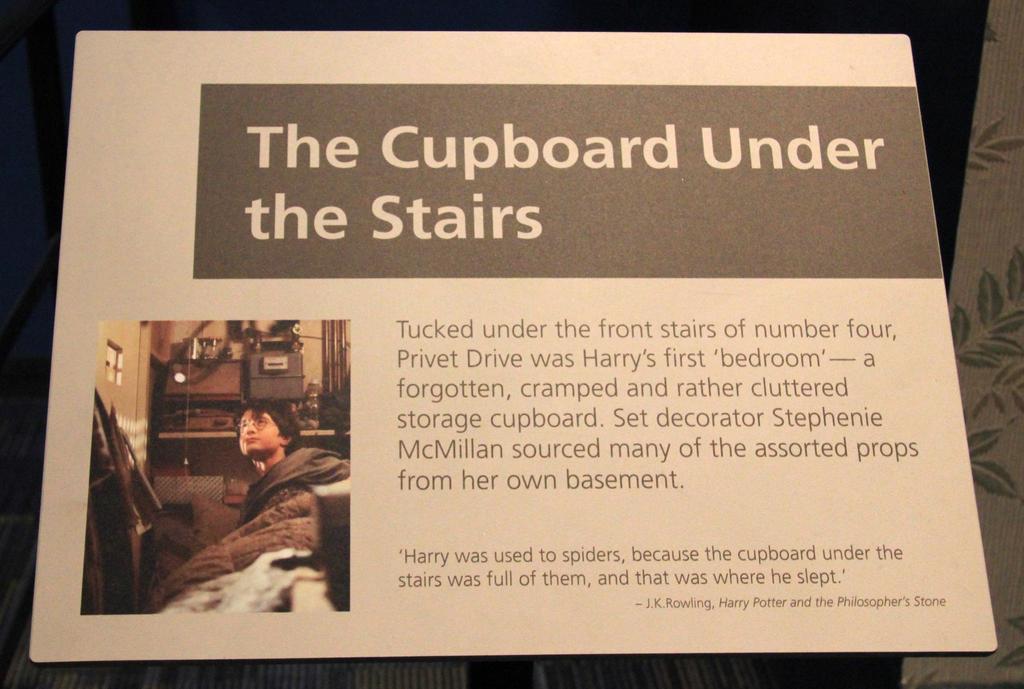Could you give a brief overview of what you see in this image? This picture is mainly highlighted with a board and we can see some information. We can see a person wearing spectacles. In this picture we can see the wall, few objects. 